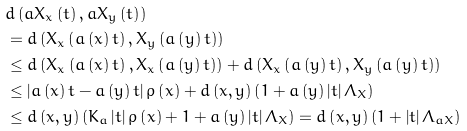<formula> <loc_0><loc_0><loc_500><loc_500>& d \left ( a X _ { x } \left ( t \right ) , a X _ { y } \left ( t \right ) \right ) \\ & = d \left ( X _ { x } \left ( a \left ( x \right ) t \right ) , X _ { y } \left ( a \left ( y \right ) t \right ) \right ) \\ & \leq d \left ( X _ { x } \left ( a \left ( x \right ) t \right ) , X _ { x } \left ( a \left ( y \right ) t \right ) \right ) + d \left ( X _ { x } \left ( a \left ( y \right ) t \right ) , X _ { y } \left ( a \left ( y \right ) t \right ) \right ) \\ & \leq \left | a \left ( x \right ) t - a \left ( y \right ) t \right | \rho \left ( x \right ) + d \left ( x , y \right ) \left ( 1 + a \left ( y \right ) \left | t \right | \Lambda _ { X } \right ) \\ & \leq d \left ( x , y \right ) \left ( K _ { a } \left | t \right | \rho \left ( x \right ) + 1 + a \left ( y \right ) \left | t \right | \Lambda _ { X } \right ) = d \left ( x , y \right ) \left ( 1 + \left | t \right | \Lambda _ { a X } \right )</formula> 